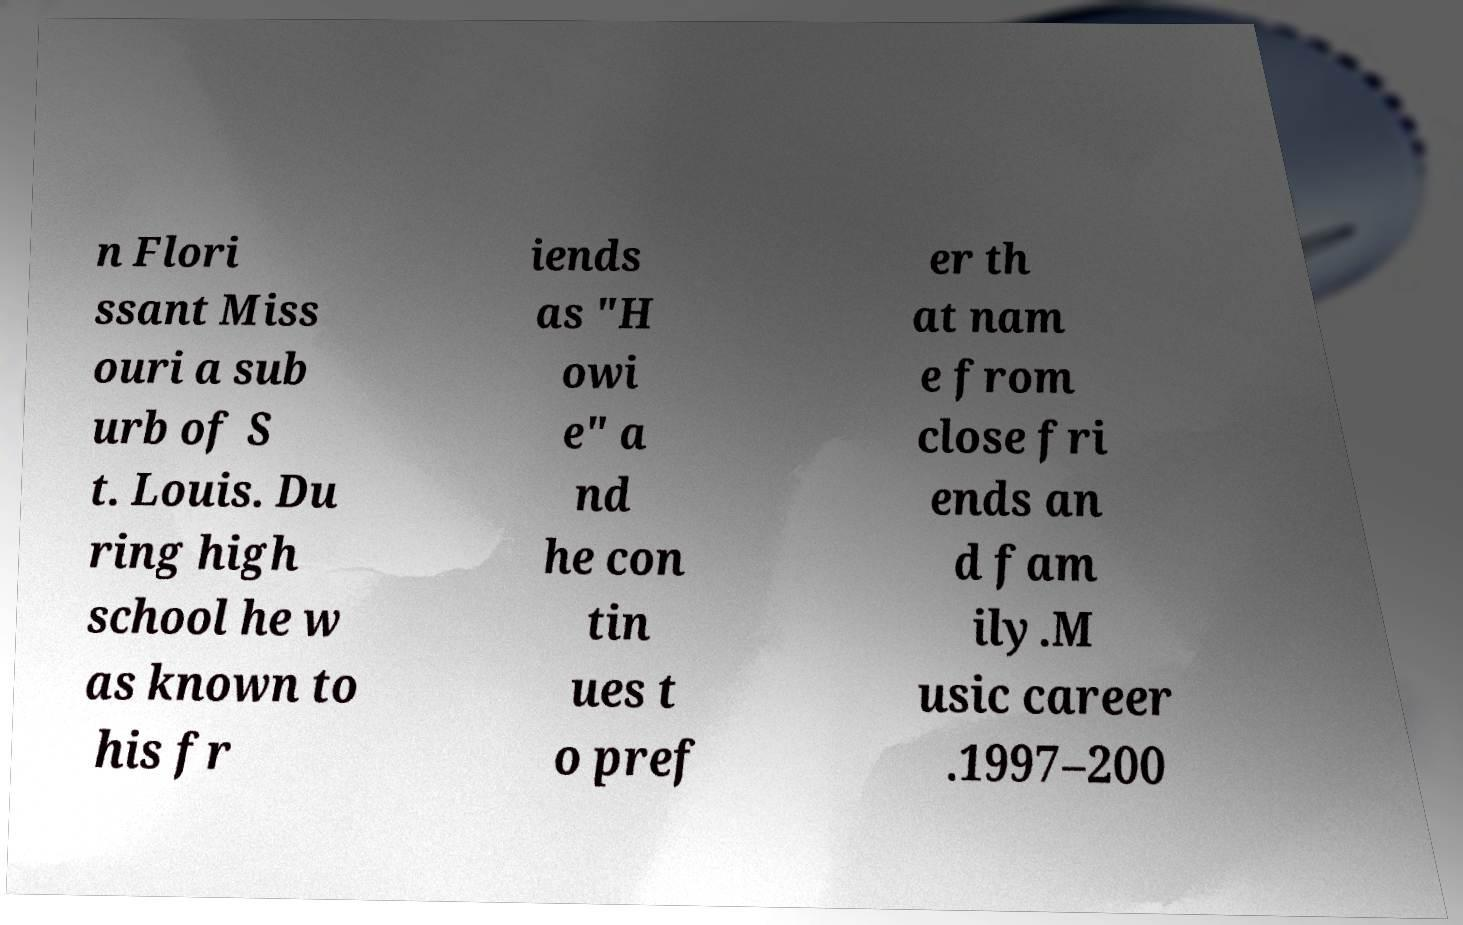Could you assist in decoding the text presented in this image and type it out clearly? n Flori ssant Miss ouri a sub urb of S t. Louis. Du ring high school he w as known to his fr iends as "H owi e" a nd he con tin ues t o pref er th at nam e from close fri ends an d fam ily.M usic career .1997–200 